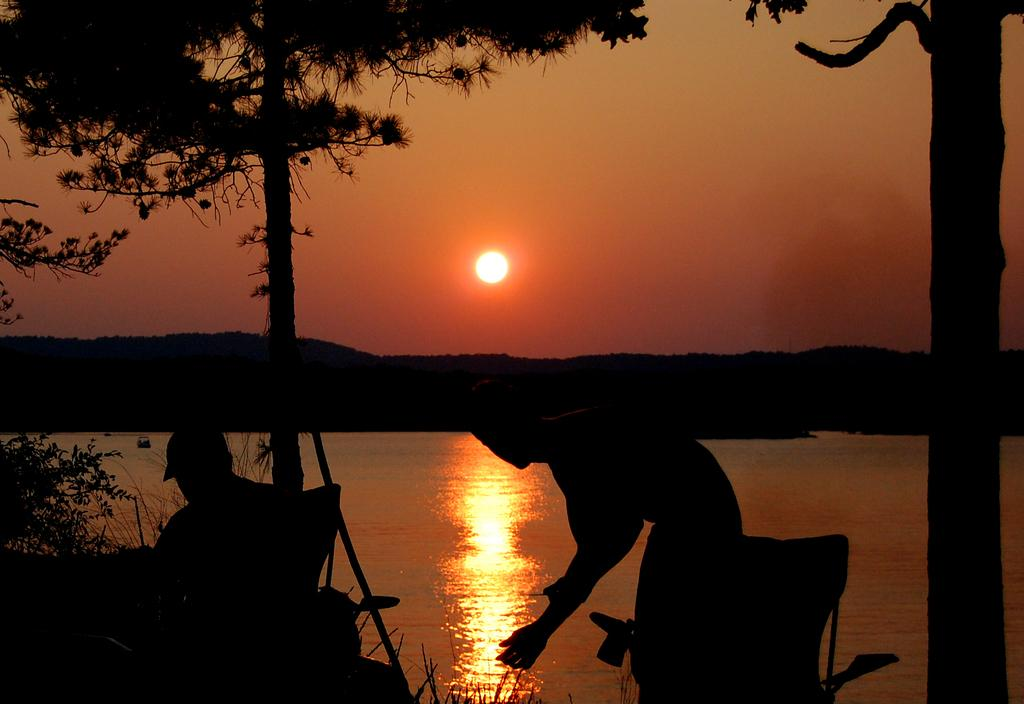What is the person in the image doing? There is a human sitting in a chair in the image. Who else is present in the image? There is a woman standing in the image. What type of natural environment can be seen in the image? Trees and water are visible in the image. What is the condition of the sky in the image? The sun is observable in the sky. How many rabbits can be seen hopping on the roof in the image? There are no rabbits or roof present in the image. What type of channel is visible in the image? There is no channel visible in the image. 